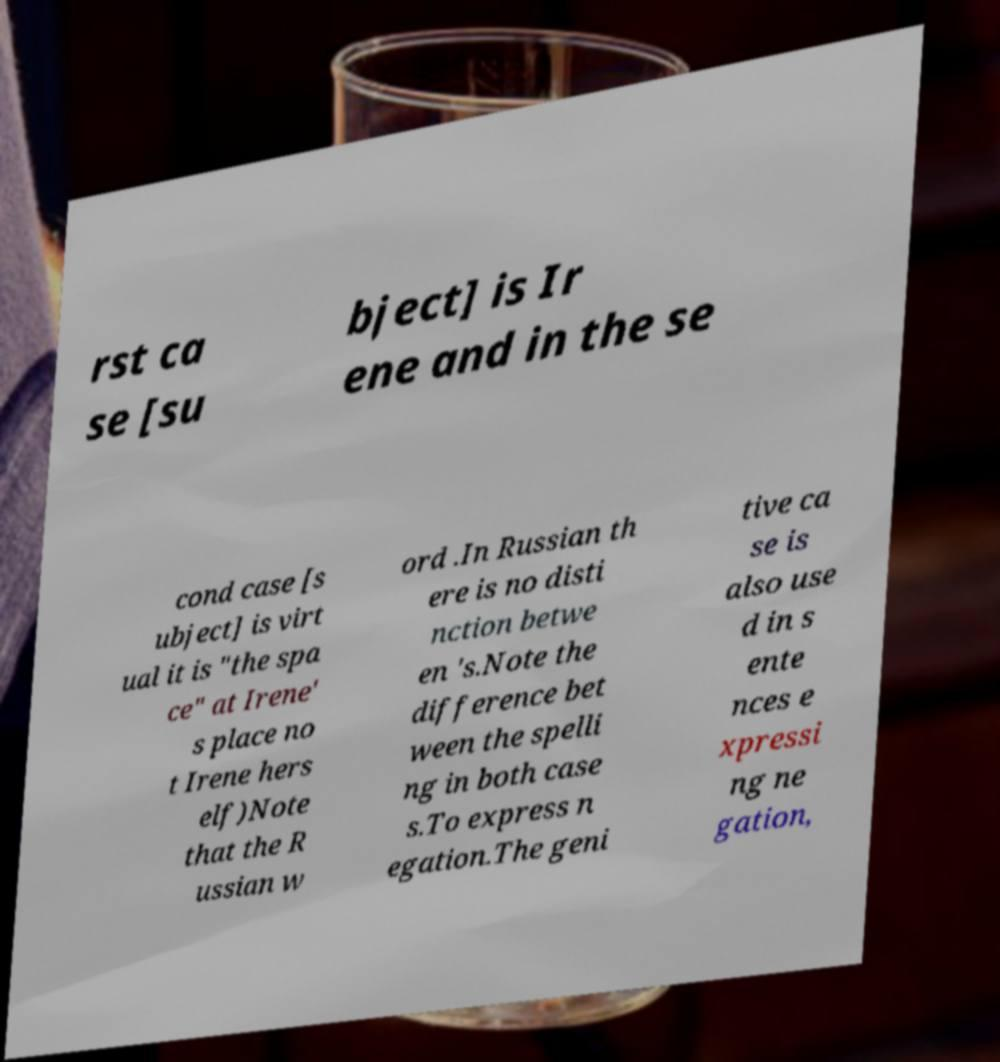What messages or text are displayed in this image? I need them in a readable, typed format. rst ca se [su bject] is Ir ene and in the se cond case [s ubject] is virt ual it is "the spa ce" at Irene' s place no t Irene hers elf)Note that the R ussian w ord .In Russian th ere is no disti nction betwe en 's.Note the difference bet ween the spelli ng in both case s.To express n egation.The geni tive ca se is also use d in s ente nces e xpressi ng ne gation, 